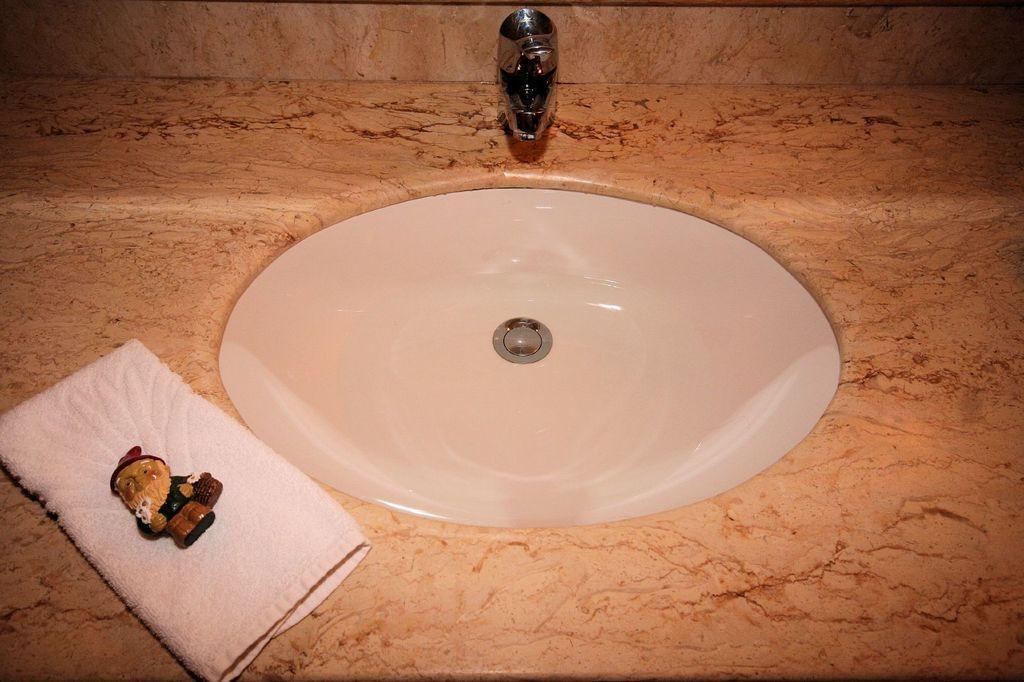In one or two sentences, can you explain what this image depicts? In this picture I can see a wash basin and a tap. I can see a napkin and a toy on it. 